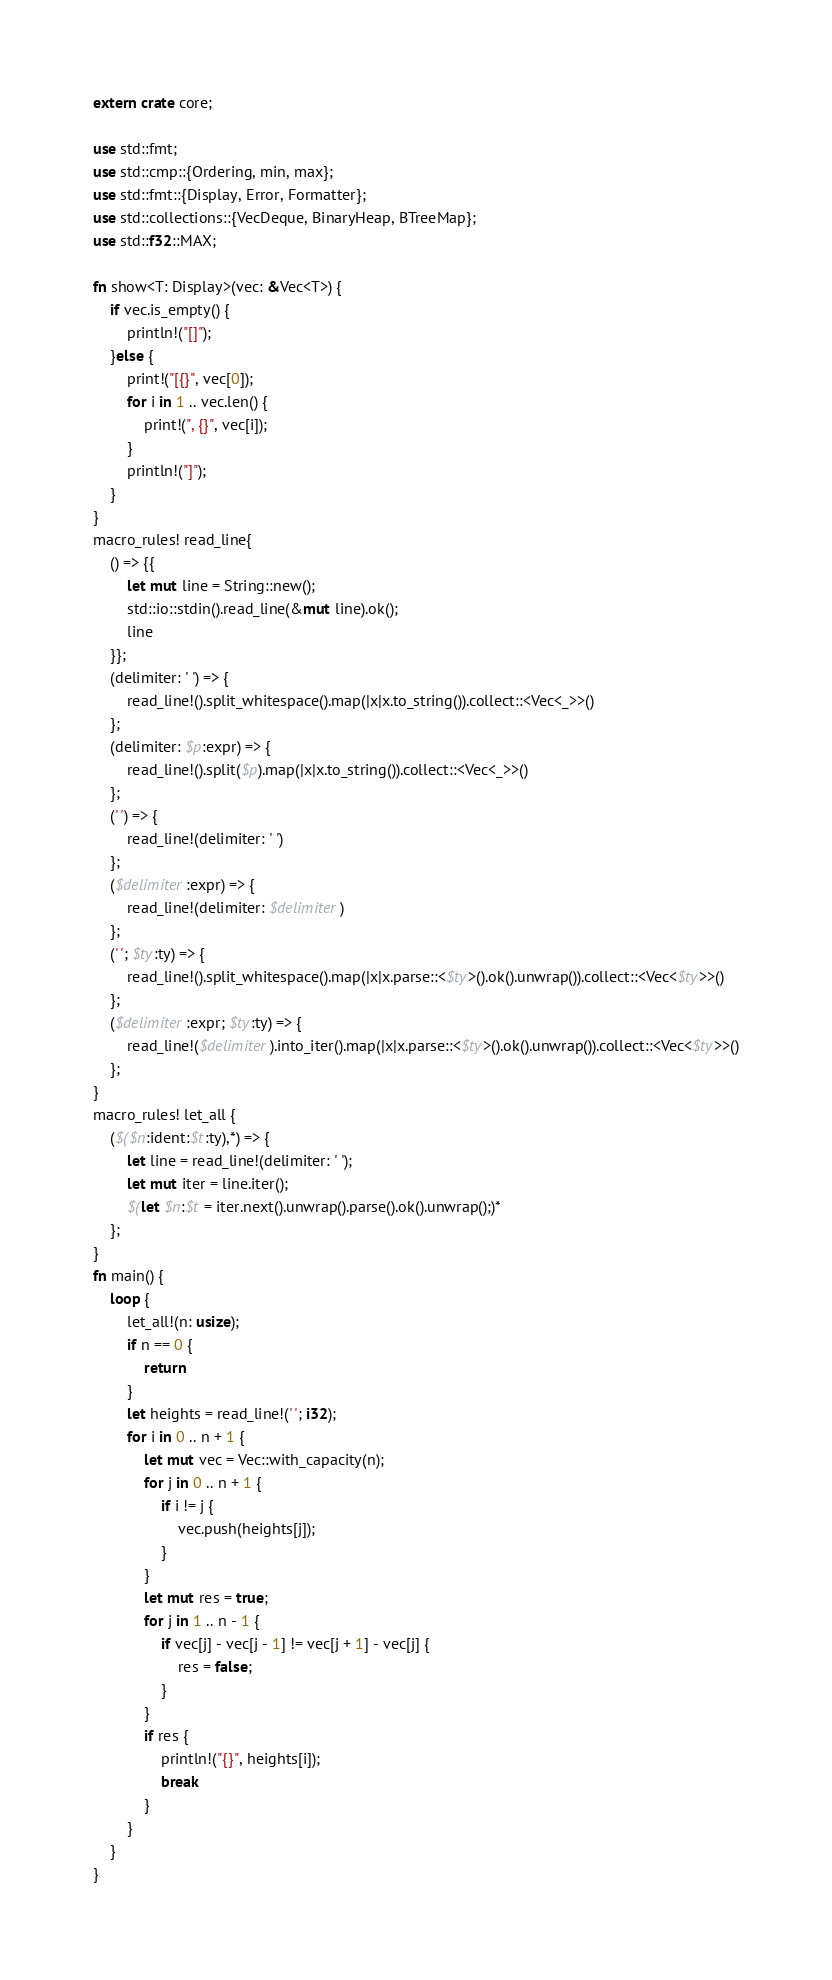Convert code to text. <code><loc_0><loc_0><loc_500><loc_500><_Rust_>extern crate core;

use std::fmt;
use std::cmp::{Ordering, min, max};
use std::fmt::{Display, Error, Formatter};
use std::collections::{VecDeque, BinaryHeap, BTreeMap};
use std::f32::MAX;

fn show<T: Display>(vec: &Vec<T>) {
    if vec.is_empty() {
        println!("[]");
    }else {
        print!("[{}", vec[0]);
        for i in 1 .. vec.len() {
            print!(", {}", vec[i]);
        }
        println!("]");
    }
}
macro_rules! read_line{
    () => {{
        let mut line = String::new();
        std::io::stdin().read_line(&mut line).ok();
        line
    }};
    (delimiter: ' ') => {
        read_line!().split_whitespace().map(|x|x.to_string()).collect::<Vec<_>>()
    };
    (delimiter: $p:expr) => {
        read_line!().split($p).map(|x|x.to_string()).collect::<Vec<_>>()
    };
    (' ') => {
        read_line!(delimiter: ' ')
    };
    ($delimiter:expr) => {
        read_line!(delimiter: $delimiter)
    };
    (' '; $ty:ty) => {
        read_line!().split_whitespace().map(|x|x.parse::<$ty>().ok().unwrap()).collect::<Vec<$ty>>()
    };
    ($delimiter:expr; $ty:ty) => {
        read_line!($delimiter).into_iter().map(|x|x.parse::<$ty>().ok().unwrap()).collect::<Vec<$ty>>()
    };
}
macro_rules! let_all {
    ($($n:ident:$t:ty),*) => {
        let line = read_line!(delimiter: ' ');
        let mut iter = line.iter();
        $(let $n:$t = iter.next().unwrap().parse().ok().unwrap();)*
    };
}
fn main() {
    loop {
        let_all!(n: usize);
        if n == 0 {
            return
        }
        let heights = read_line!(' '; i32);
        for i in 0 .. n + 1 {
            let mut vec = Vec::with_capacity(n);
            for j in 0 .. n + 1 {
                if i != j {
                    vec.push(heights[j]);
                }
            }
            let mut res = true;
            for j in 1 .. n - 1 {
                if vec[j] - vec[j - 1] != vec[j + 1] - vec[j] {
                    res = false;
                }
            }
            if res {
                println!("{}", heights[i]);
                break
            }
        }
    }
}

</code> 